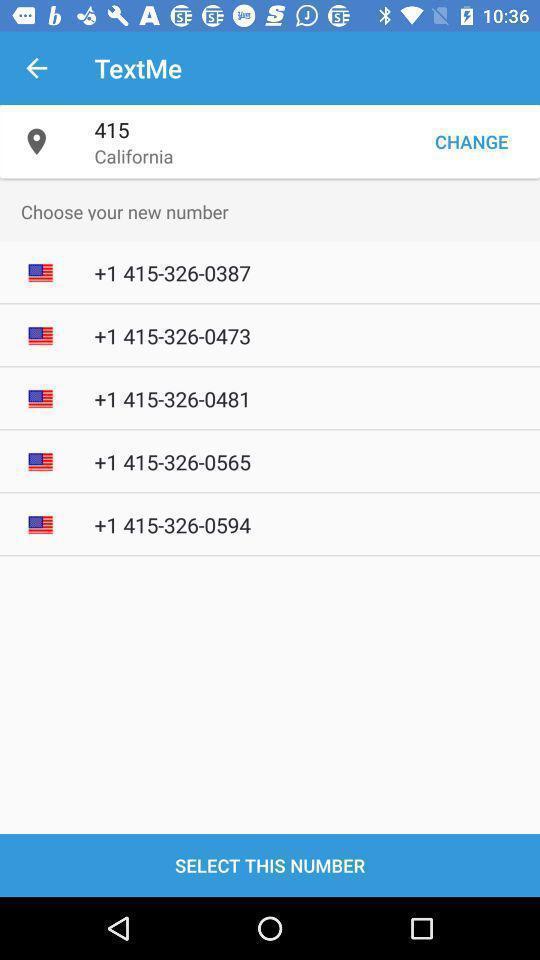Explain the elements present in this screenshot. Screen shows contact details in a call application. 